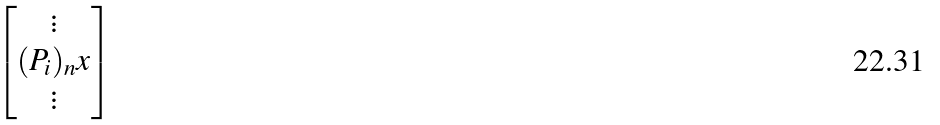<formula> <loc_0><loc_0><loc_500><loc_500>\begin{bmatrix} \vdots \\ ( P _ { i } ) _ { n } x \\ \vdots \end{bmatrix}</formula> 